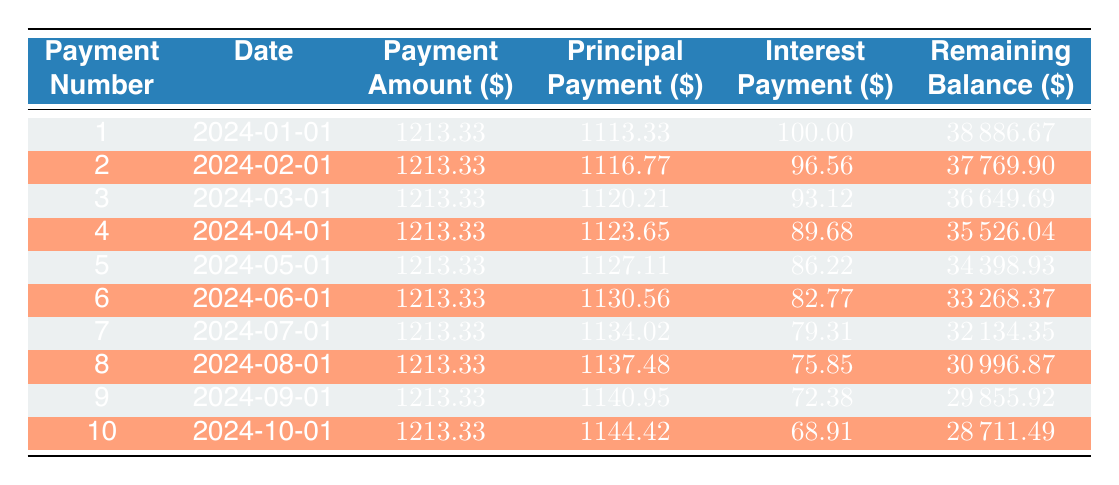What is the total financed amount for the equipment? The total financed amount is explicitly stated in the loan details section of the data, which indicates a financed amount of 40000.
Answer: 40000 What is the interest payment in the 5th payment? Looking at the amortization schedule, the interest payment for payment number 5 is clearly listed as 86.22.
Answer: 86.22 What is the remaining balance after the 3rd payment? The remaining balance is shown in the schedule, and after the 3rd payment, it amounts to 36649.69.
Answer: 36649.69 Is the interest payment decreasing over the payment period? By examining the interest payments for each of the 10 payments, it is evident that the interest payment reduces with each subsequent payment, thus confirming it is decreasing.
Answer: Yes What is the total amount paid in principal after the first 6 payments? The principal payments for the first 6 payments are 1113.33, 1116.77, 1120.21, 1123.65, 1127.11, and 1130.56. Adding these gives a total of 1113.33 + 1116.77 + 1120.21 + 1123.65 + 1127.11 + 1130.56 = 6740.63.
Answer: 6740.63 What is the average payment amount over the first 10 payments? The payment amount for each month is consistently 1213.33 for all 10 payments. Averaging this over 10 payments gives 1213.33, as all payments are equal.
Answer: 1213.33 What is the difference in remaining balance between the first and the last payment? The remaining balance after the 1st payment is 38886.67, and after the 10th payment, it is 28711.49. The difference is calculated as 38886.67 - 28711.49 = 10175.18.
Answer: 10175.18 What is the principal payment in the 7th payment? From the 7th entry of the amortization schedule, the principal payment is 1134.02.
Answer: 1134.02 